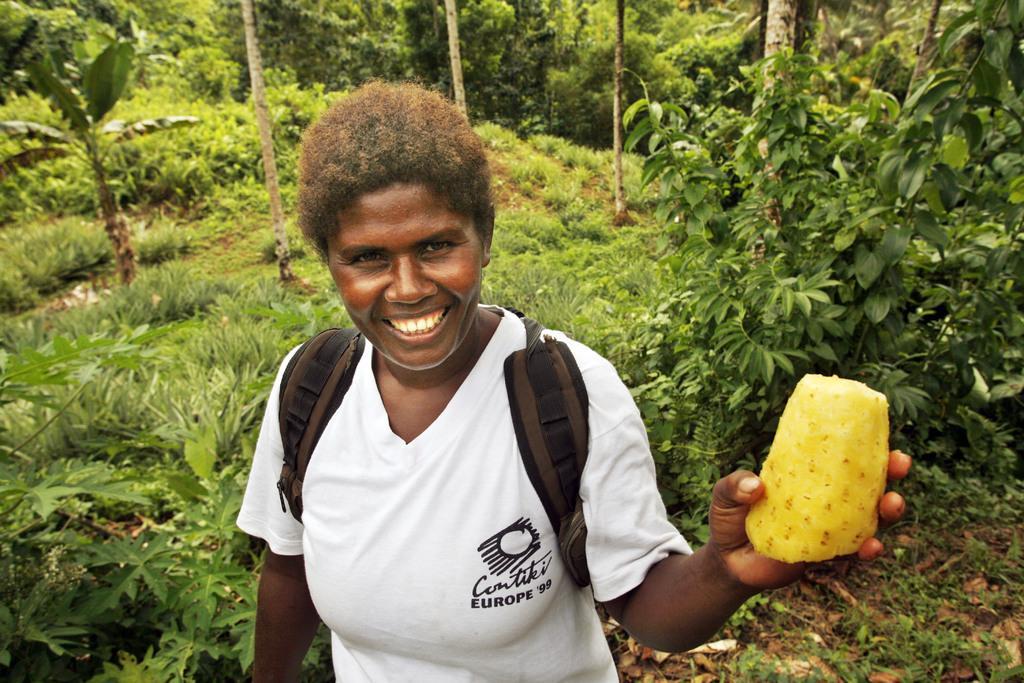Can you describe this image briefly? In this image I can see a person wearing white colored dress and bag is standing and holding a pineapple in her hands which is yellow in color. In the background I can see few trees and some grass on the ground. 